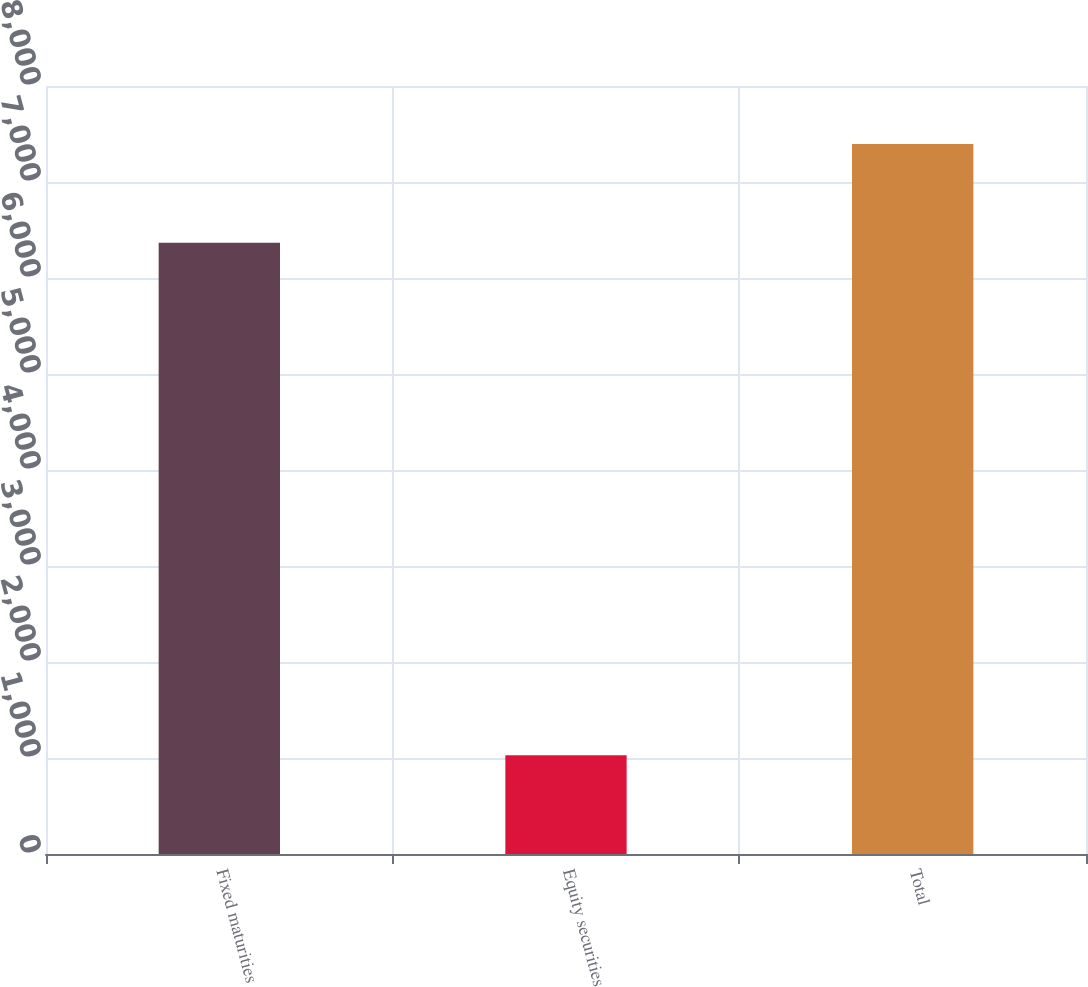Convert chart to OTSL. <chart><loc_0><loc_0><loc_500><loc_500><bar_chart><fcel>Fixed maturities<fcel>Equity securities<fcel>Total<nl><fcel>6367<fcel>1028<fcel>7395<nl></chart> 